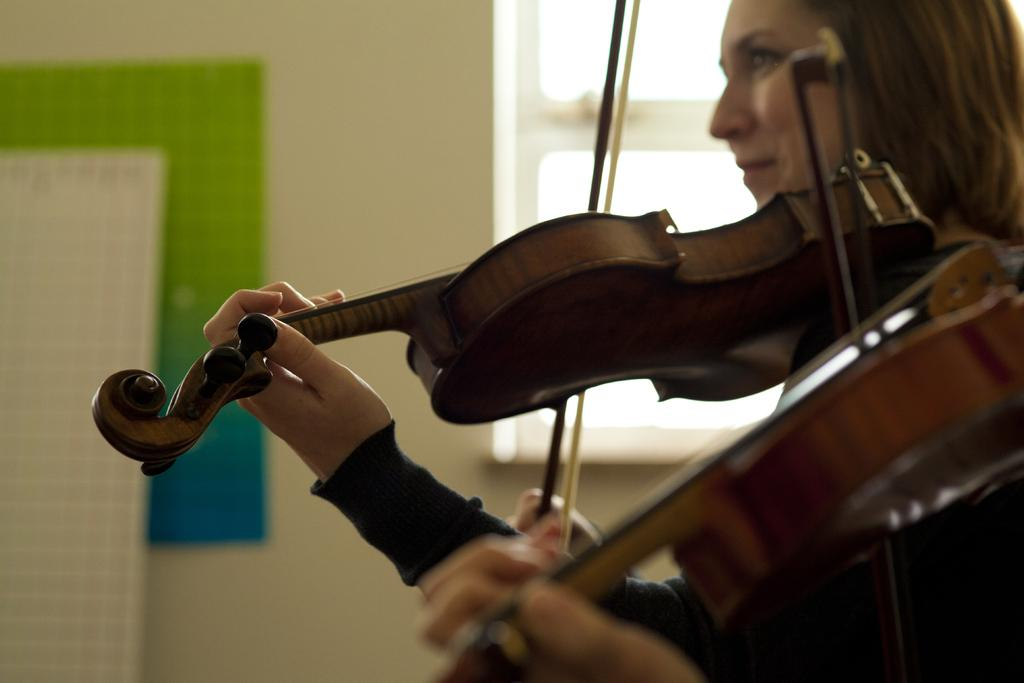Who is the main subject in the image? There is a woman in the image. What is the woman doing in the image? The woman is playing the violin. What is the woman's facial expression in the image? The woman is smiling. What can be seen in the background of the image? There is a wall and a window in the image. What type of line is visible on the woman's shirt in the image? There is no line visible on the woman's shirt in the image, nor is there any mention of a shirt in the provided facts. 